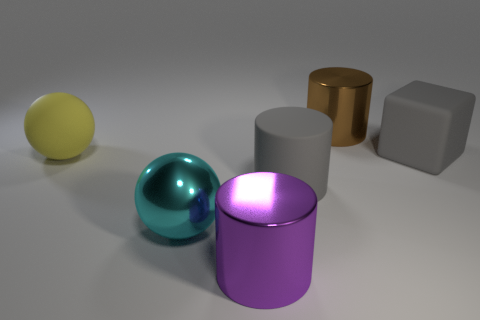Add 4 big matte balls. How many objects exist? 10 Subtract all balls. How many objects are left? 4 Add 6 big brown metal cylinders. How many big brown metal cylinders exist? 7 Subtract 0 purple cubes. How many objects are left? 6 Subtract all purple matte objects. Subtract all cubes. How many objects are left? 5 Add 4 brown objects. How many brown objects are left? 5 